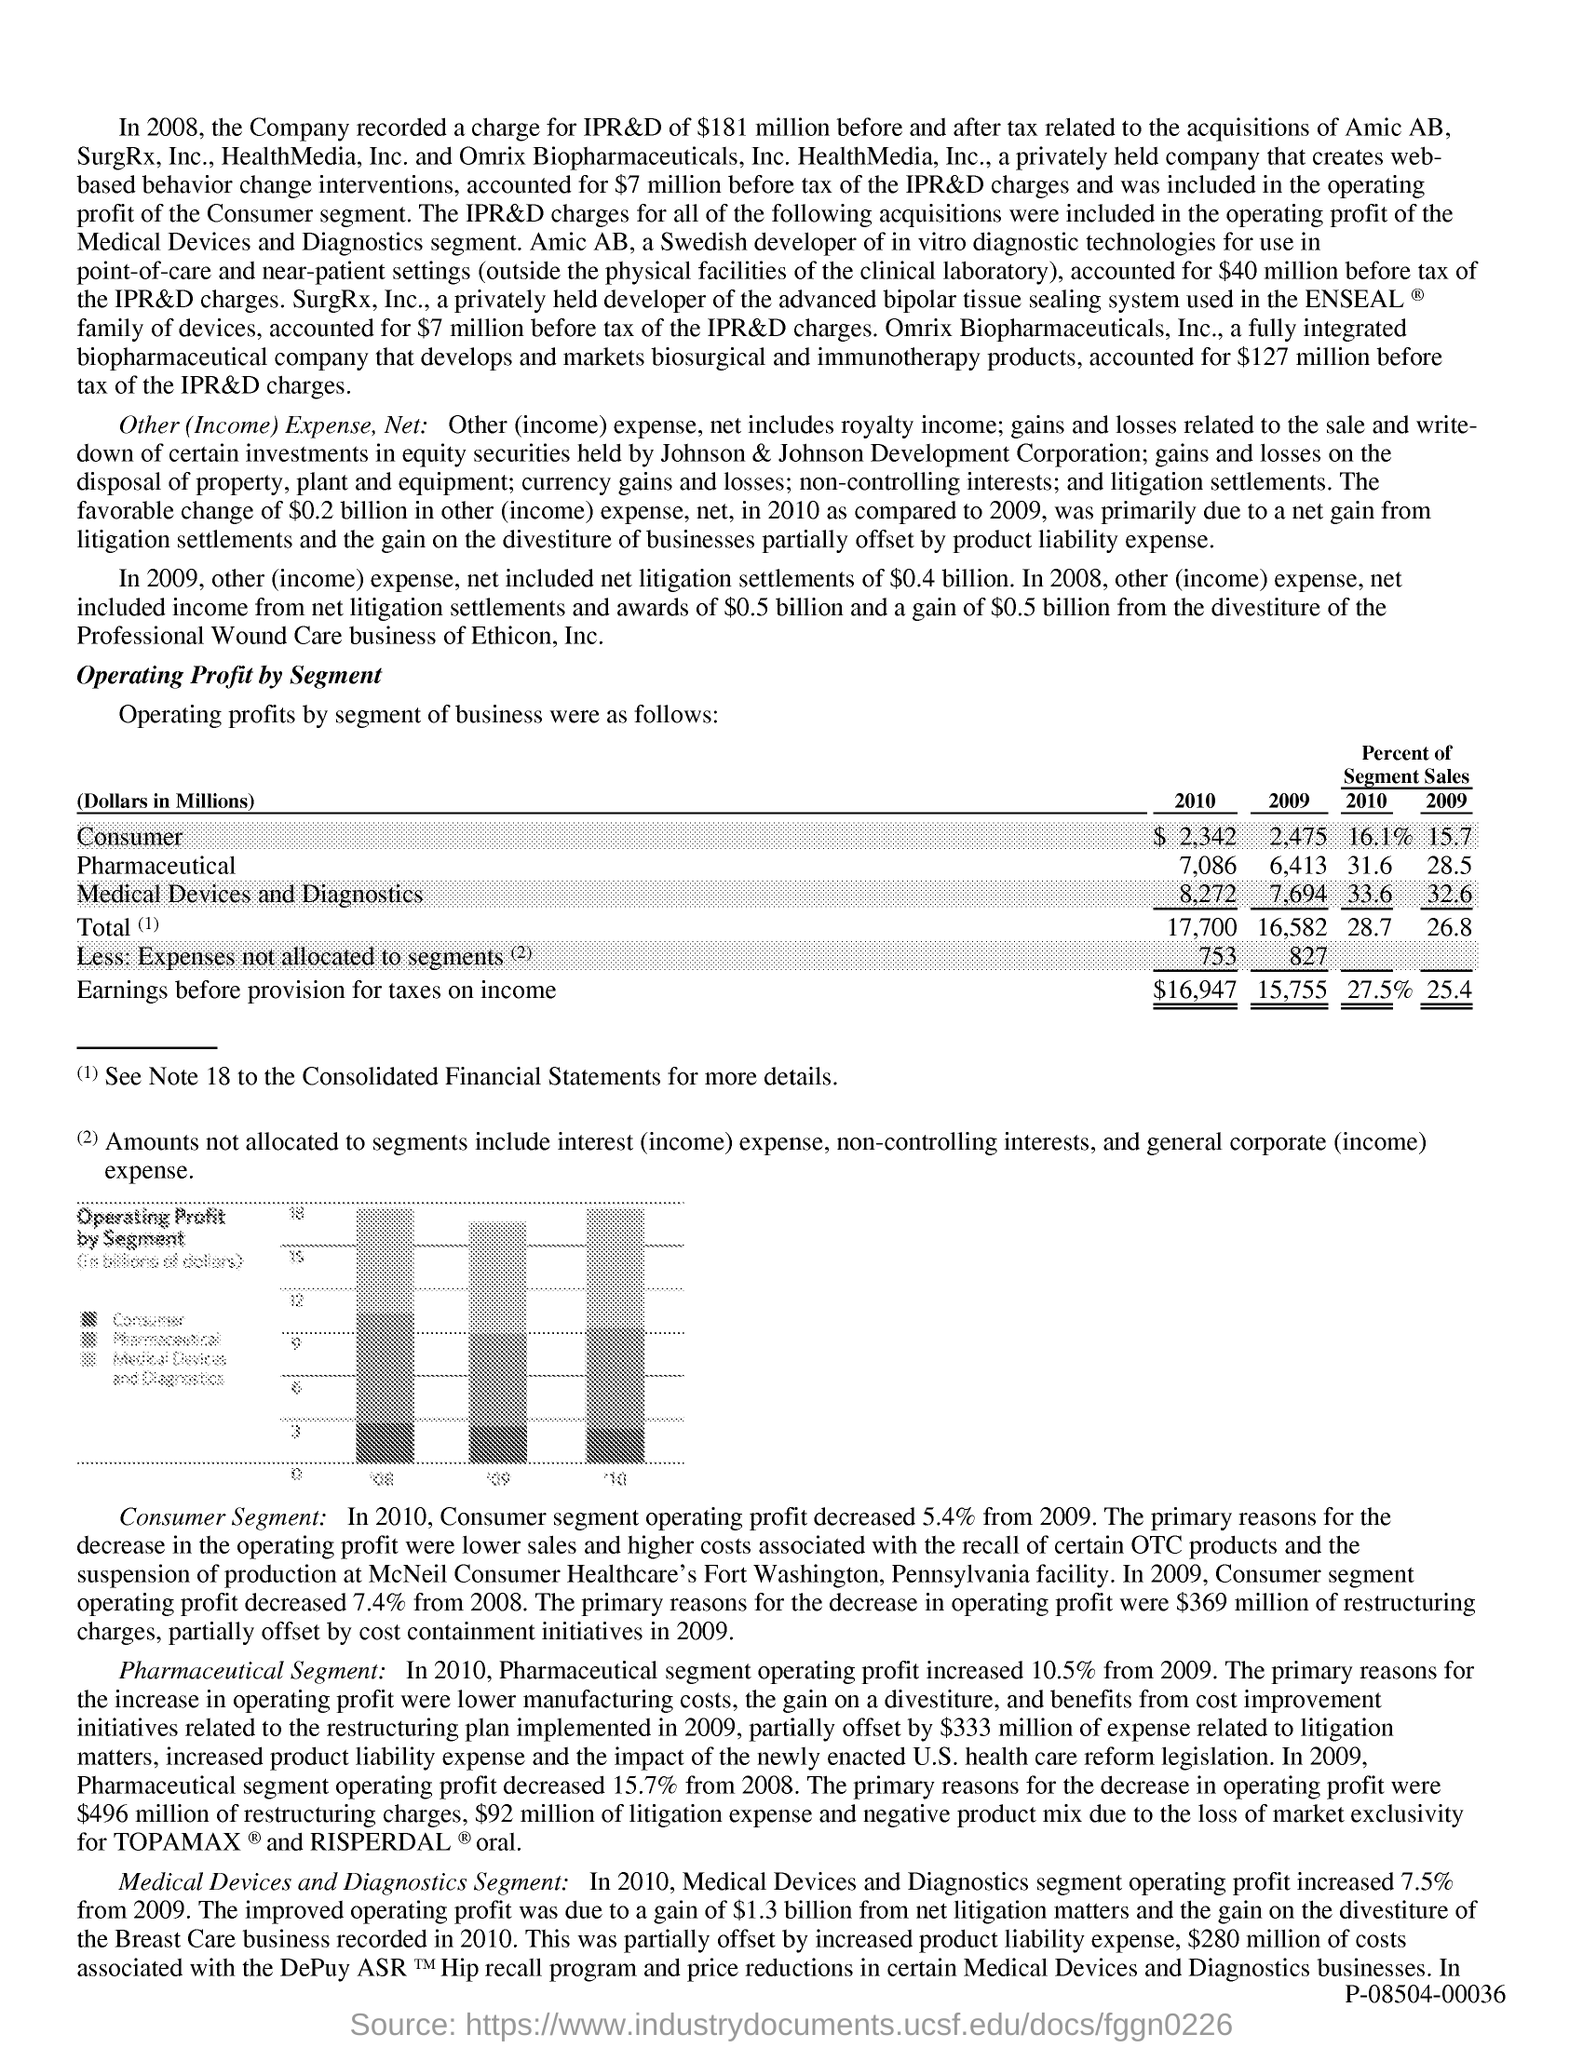Specify some key components in this picture. The document is titled "Operating Profit by Segment. 